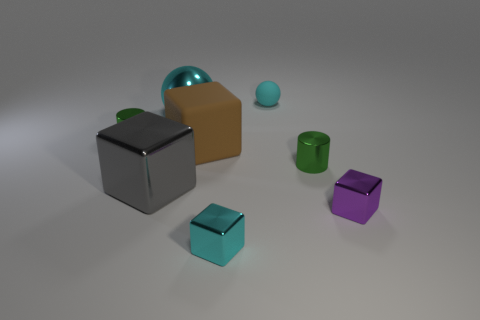What shapes are visible in the scene, and what might they signify? There are several shapes visible: cubes, cylinders, and a sphere. These shapes could represent different elements in a minimalist composition, possibly suggesting simplicity and order. Could this assortment of objects and colors have a deeper meaning? Potentially, the assorted objects and colors might symbolize diversity and unity, with distinct shapes and hues coexisting harmoniously within the same space. 